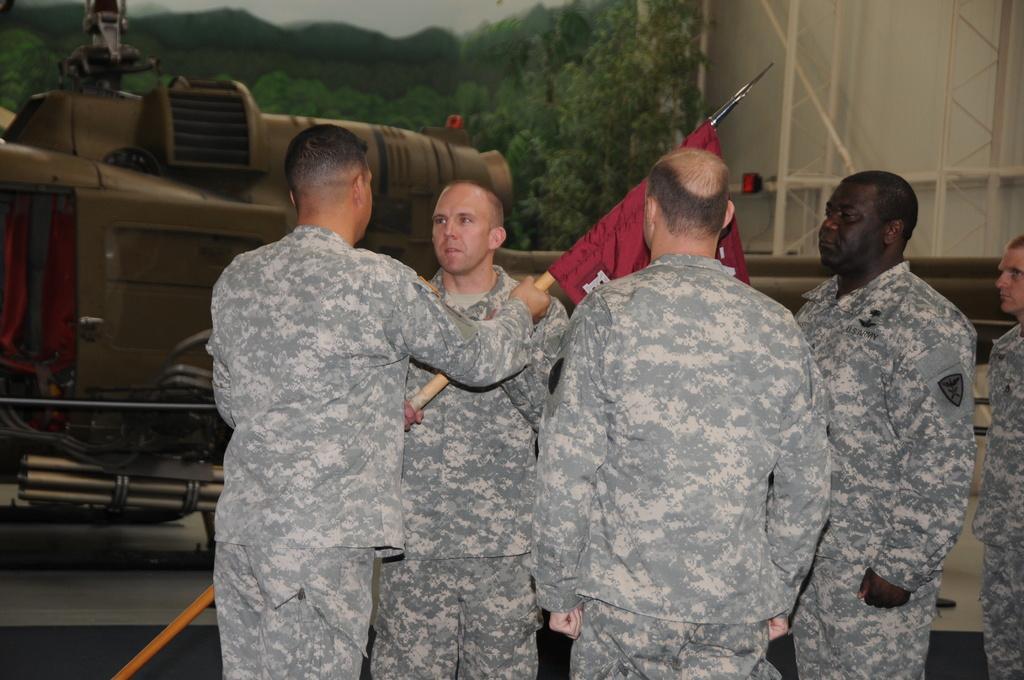Could you give a brief overview of what you see in this image? In the center of the image we can see people standing. They are wearing uniforms. The man standing on the left is holding a flag in his hand. In the background there is a train, trees and a wall. 